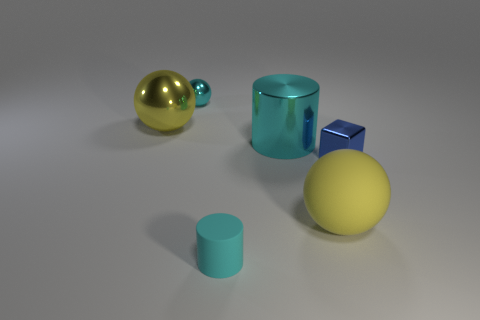There is a big metallic thing that is the same color as the big matte ball; what is its shape?
Offer a terse response. Sphere. Does the small metal ball have the same color as the big rubber sphere?
Offer a very short reply. No. There is a ball that is both on the right side of the large shiny sphere and behind the small metal block; what is its material?
Make the answer very short. Metal. What size is the blue metallic object?
Give a very brief answer. Small. How many balls are behind the big ball on the left side of the cylinder on the left side of the large cyan cylinder?
Provide a succinct answer. 1. What shape is the yellow thing that is on the right side of the tiny object that is behind the big yellow shiny ball?
Your answer should be very brief. Sphere. What is the size of the cyan rubber thing that is the same shape as the large cyan metallic thing?
Ensure brevity in your answer.  Small. Is there anything else that is the same size as the rubber cylinder?
Offer a terse response. Yes. There is a cylinder to the right of the matte cylinder; what color is it?
Offer a terse response. Cyan. The yellow sphere that is right of the metallic ball that is on the left side of the cyan object left of the small rubber thing is made of what material?
Your answer should be compact. Rubber. 